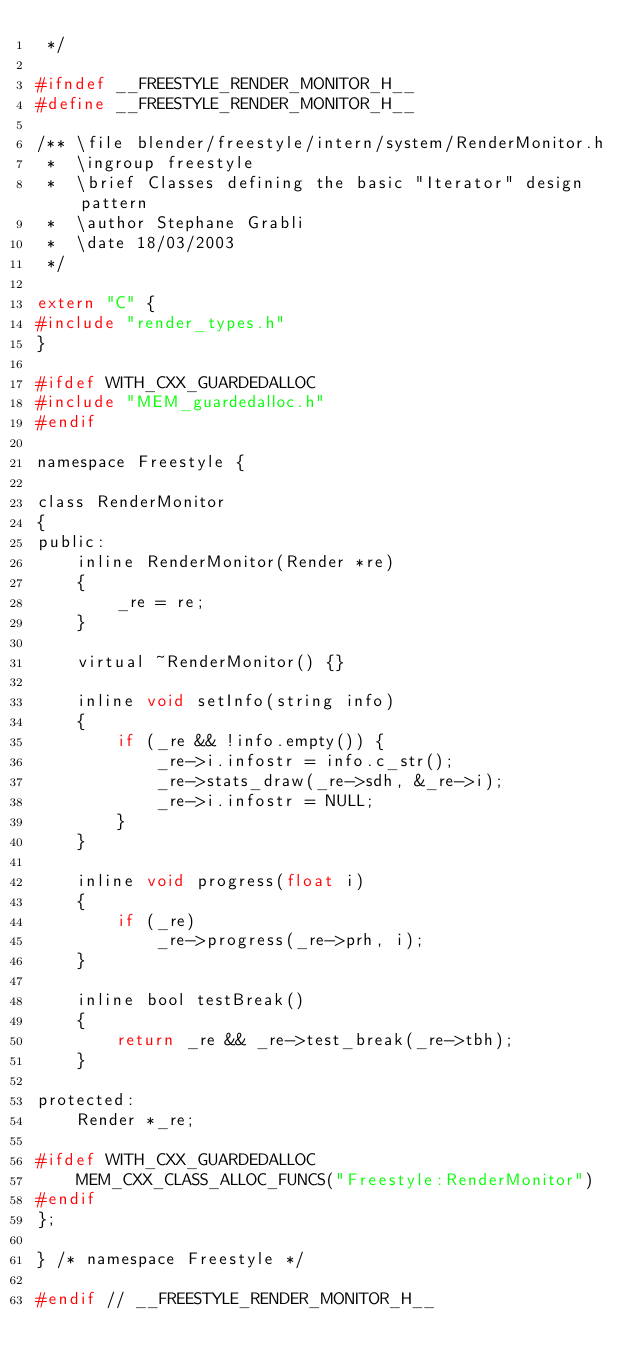<code> <loc_0><loc_0><loc_500><loc_500><_C_> */

#ifndef __FREESTYLE_RENDER_MONITOR_H__
#define __FREESTYLE_RENDER_MONITOR_H__

/** \file blender/freestyle/intern/system/RenderMonitor.h
 *  \ingroup freestyle
 *  \brief Classes defining the basic "Iterator" design pattern
 *  \author Stephane Grabli
 *  \date 18/03/2003
 */

extern "C" {
#include "render_types.h"
}

#ifdef WITH_CXX_GUARDEDALLOC
#include "MEM_guardedalloc.h"
#endif

namespace Freestyle {

class RenderMonitor
{
public:
	inline RenderMonitor(Render *re)
	{
		_re = re;
	}

	virtual ~RenderMonitor() {}

	inline void setInfo(string info)
	{
		if (_re && !info.empty()) {
			_re->i.infostr = info.c_str();
			_re->stats_draw(_re->sdh, &_re->i);
			_re->i.infostr = NULL;
		}
	}

	inline void progress(float i)
	{
		if (_re)
			_re->progress(_re->prh, i);
	}

	inline bool testBreak()
	{
		return _re && _re->test_break(_re->tbh);
	}

protected:
	Render *_re;

#ifdef WITH_CXX_GUARDEDALLOC
	MEM_CXX_CLASS_ALLOC_FUNCS("Freestyle:RenderMonitor")
#endif
};

} /* namespace Freestyle */

#endif // __FREESTYLE_RENDER_MONITOR_H__
</code> 